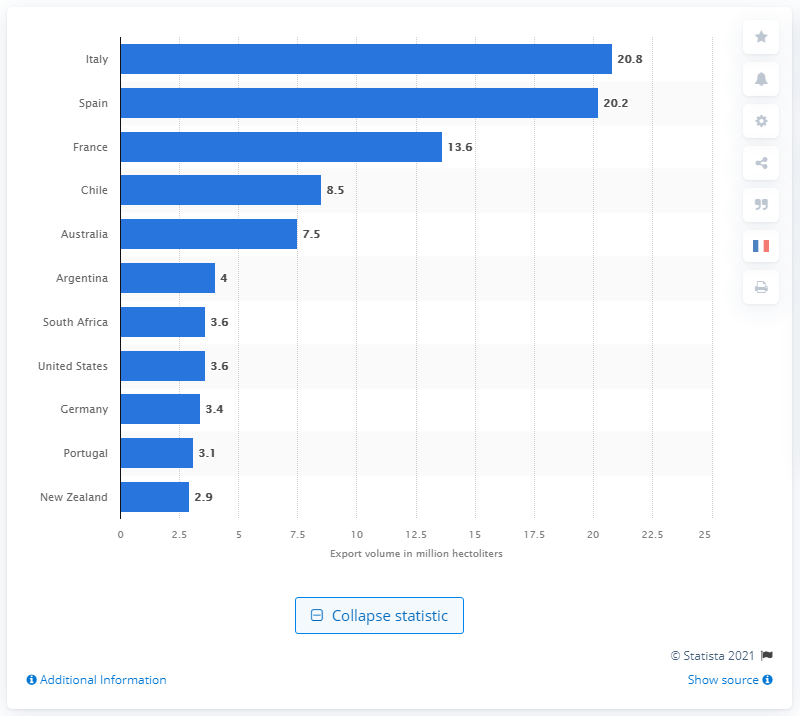Specify some key components in this picture. In 2020, Italy shipped a total of 20.8 hectoliters of wine. In 2020, Italy was the leading exporter of wine globally. 